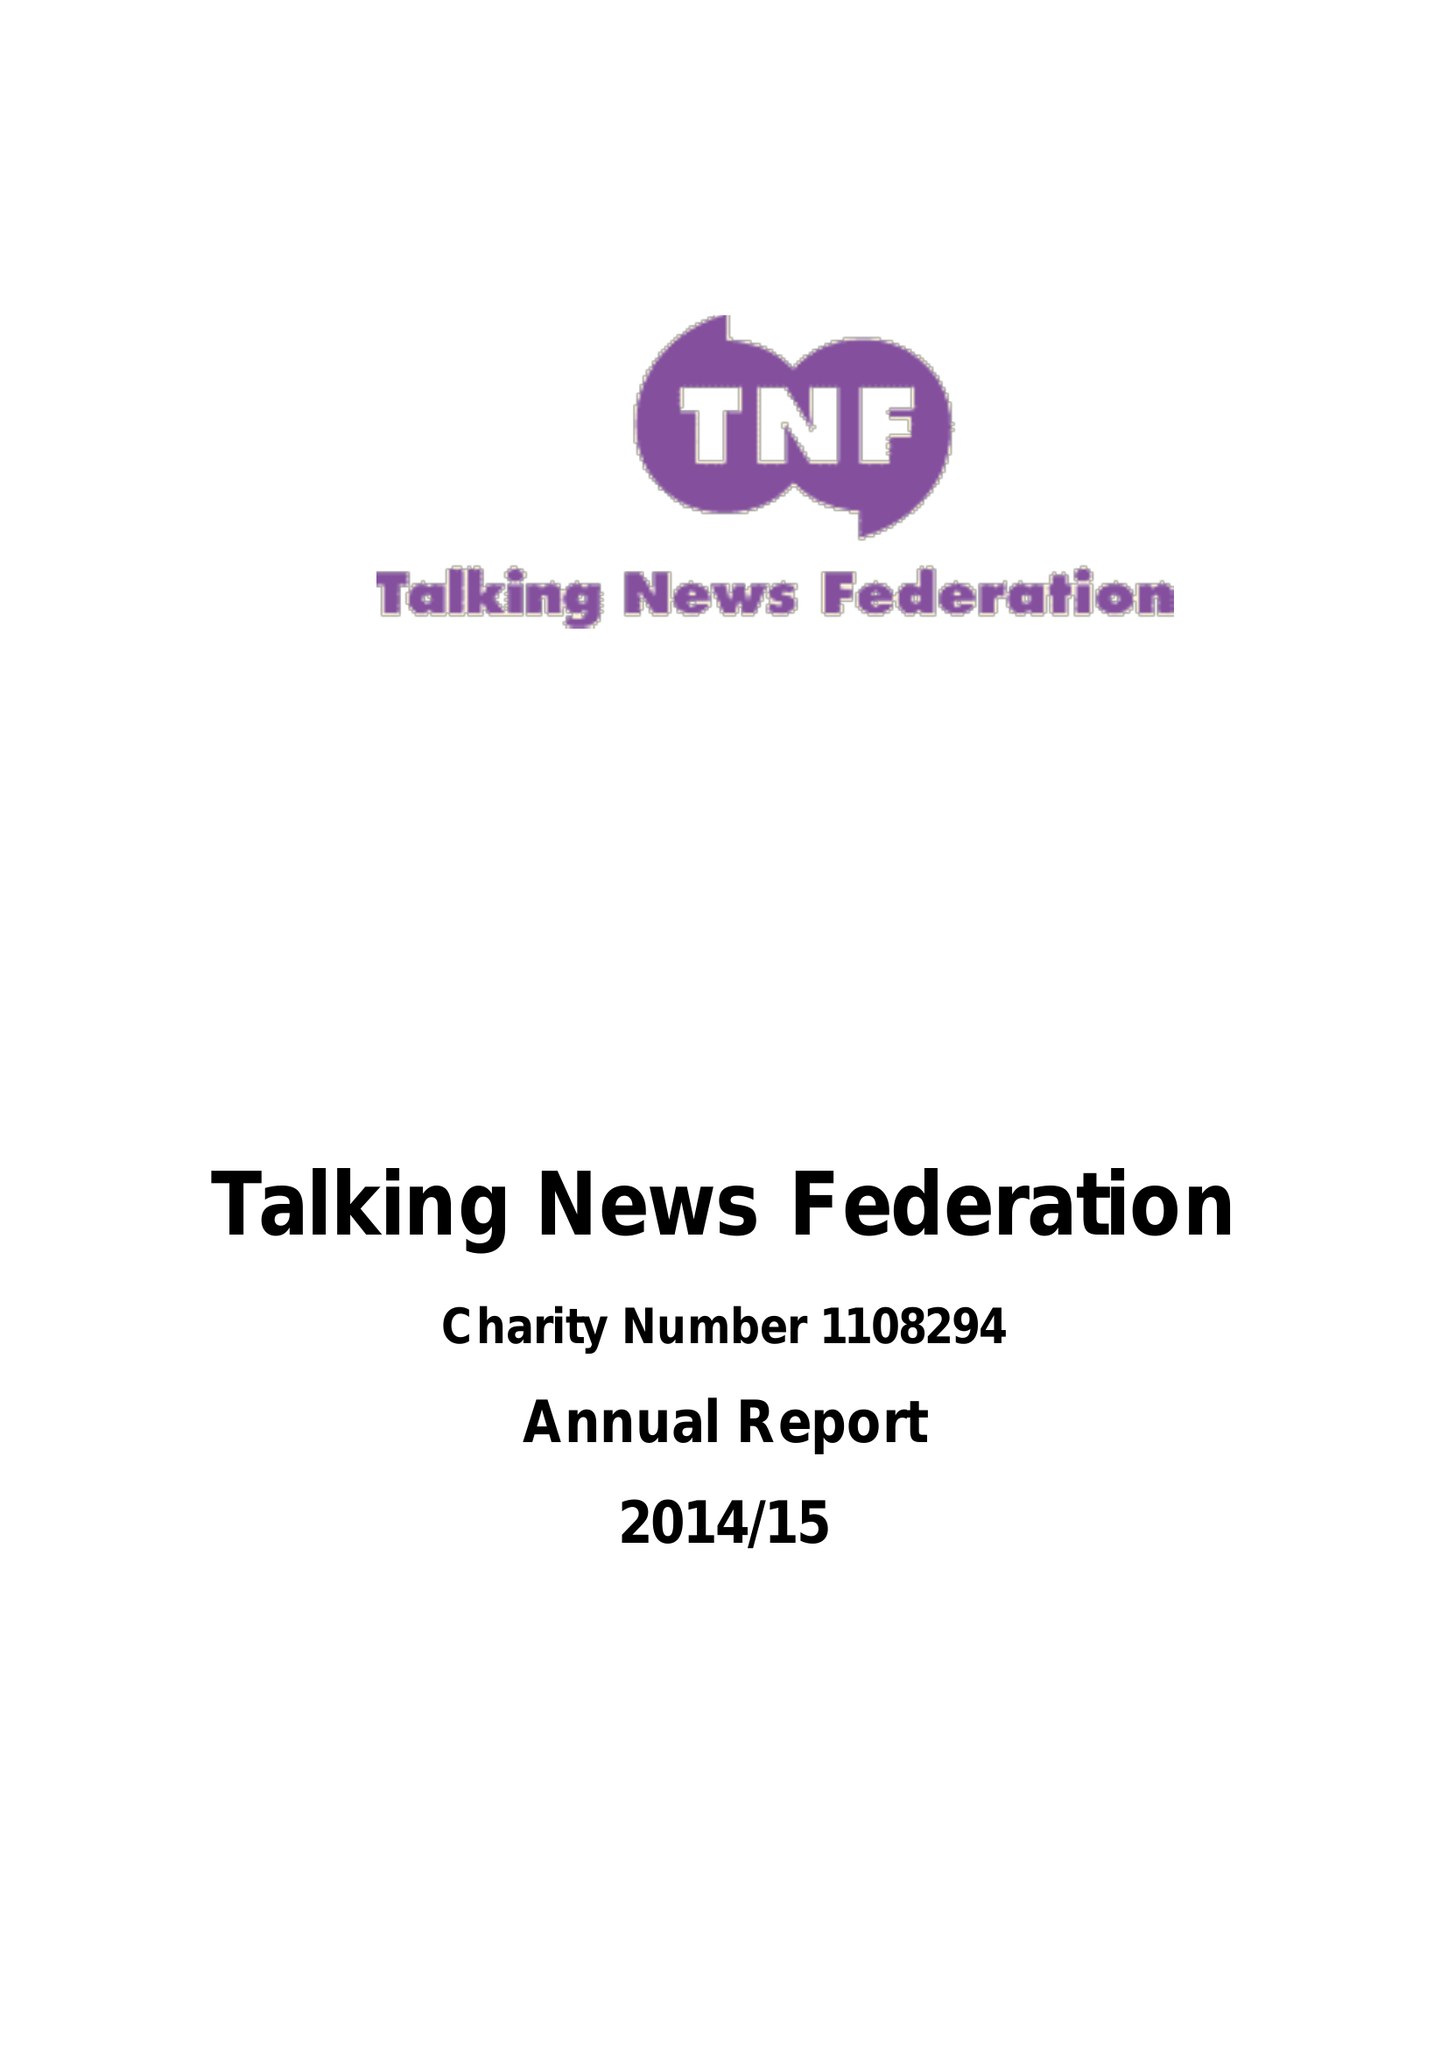What is the value for the income_annually_in_british_pounds?
Answer the question using a single word or phrase. 33547.97 